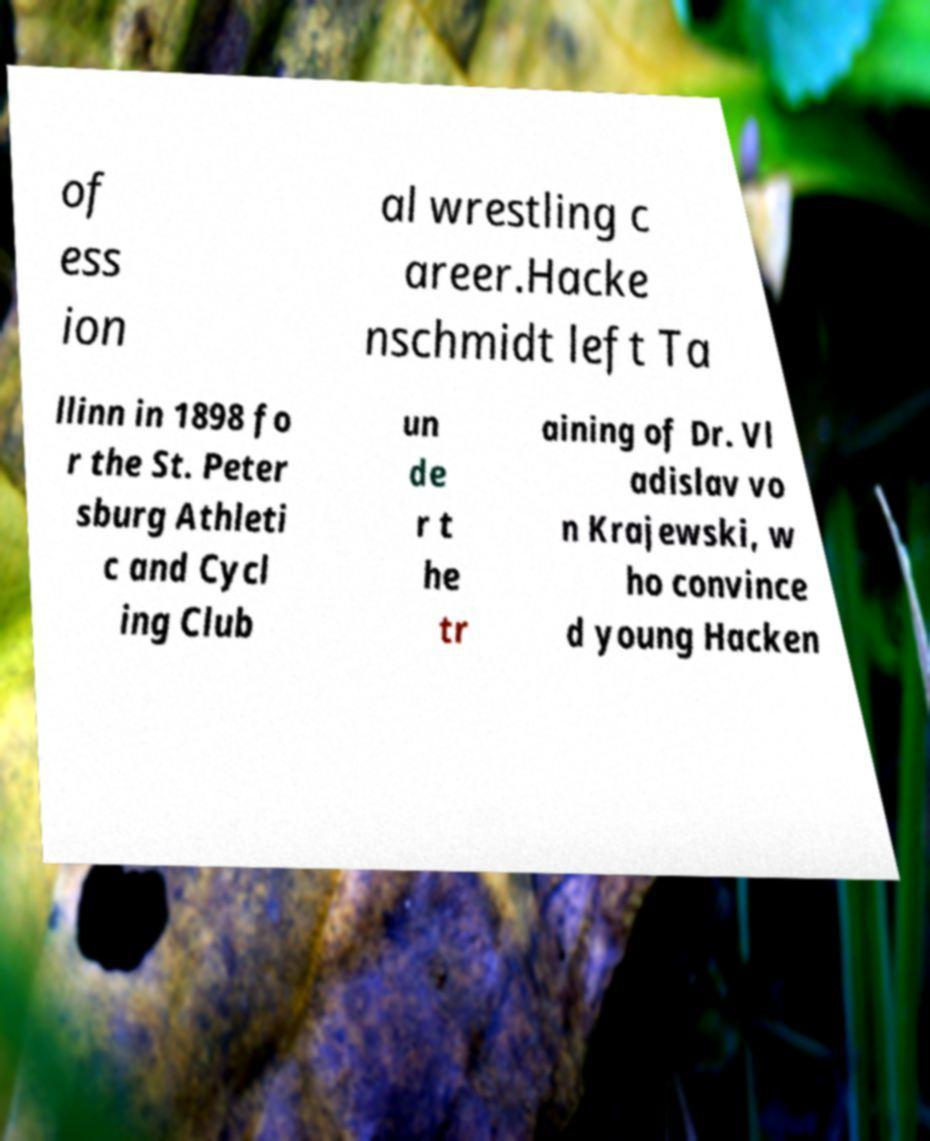For documentation purposes, I need the text within this image transcribed. Could you provide that? of ess ion al wrestling c areer.Hacke nschmidt left Ta llinn in 1898 fo r the St. Peter sburg Athleti c and Cycl ing Club un de r t he tr aining of Dr. Vl adislav vo n Krajewski, w ho convince d young Hacken 